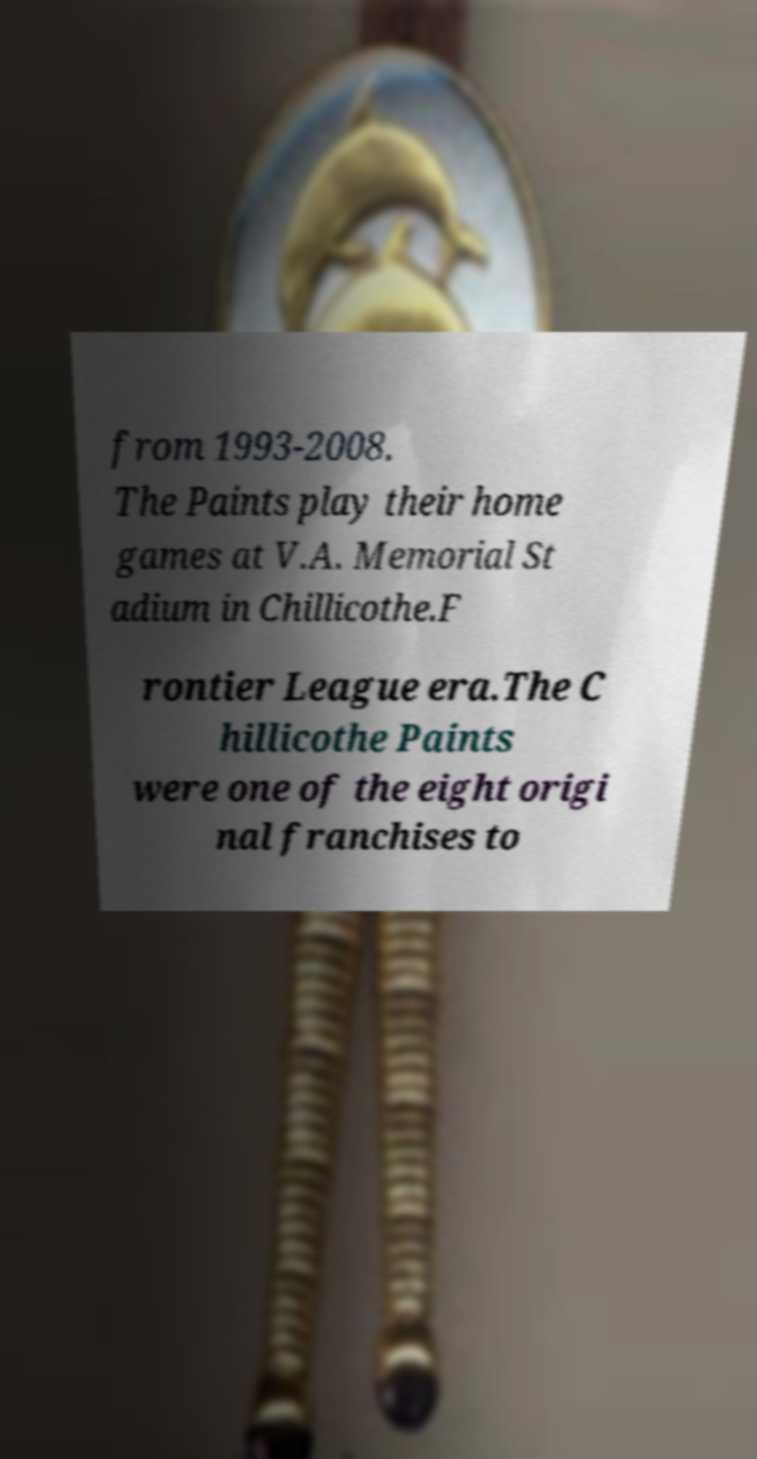I need the written content from this picture converted into text. Can you do that? from 1993-2008. The Paints play their home games at V.A. Memorial St adium in Chillicothe.F rontier League era.The C hillicothe Paints were one of the eight origi nal franchises to 